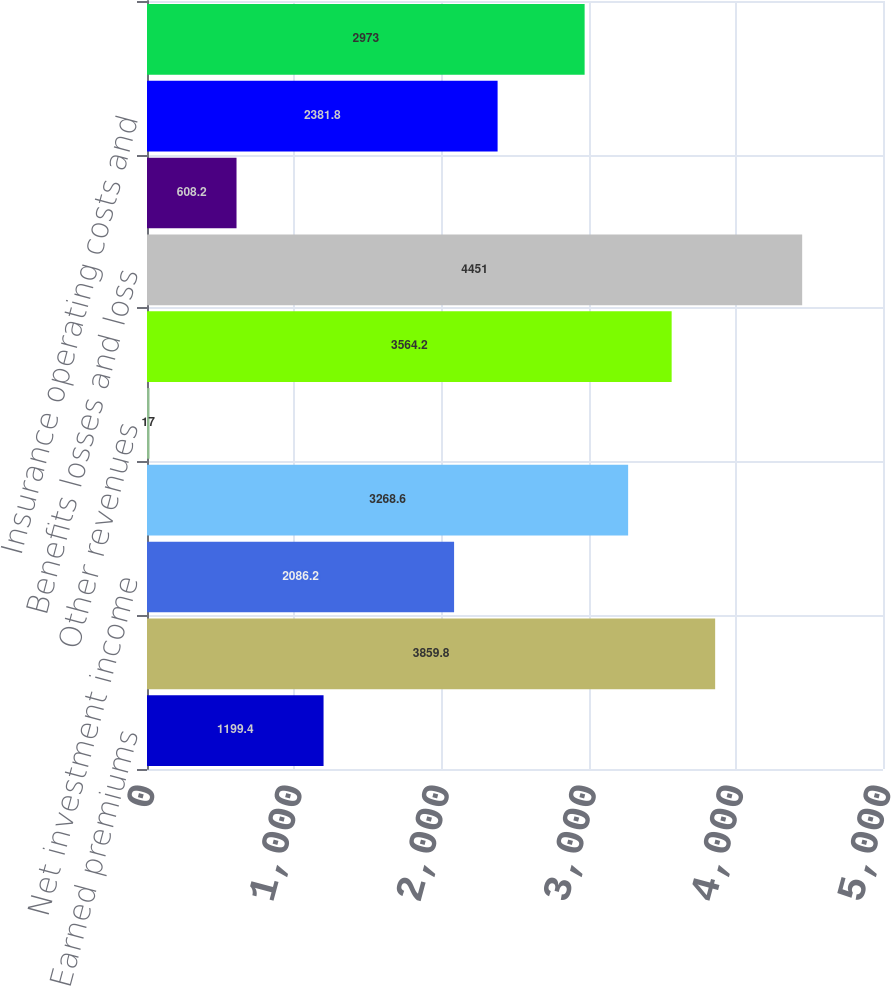Convert chart. <chart><loc_0><loc_0><loc_500><loc_500><bar_chart><fcel>Earned premiums<fcel>Fee income<fcel>Net investment income<fcel>Net realized capital gains 1<fcel>Other revenues<fcel>Total revenues<fcel>Benefits losses and loss<fcel>Amortization of deferred<fcel>Insurance operating costs and<fcel>Reinsurance (gain) loss on<nl><fcel>1199.4<fcel>3859.8<fcel>2086.2<fcel>3268.6<fcel>17<fcel>3564.2<fcel>4451<fcel>608.2<fcel>2381.8<fcel>2973<nl></chart> 